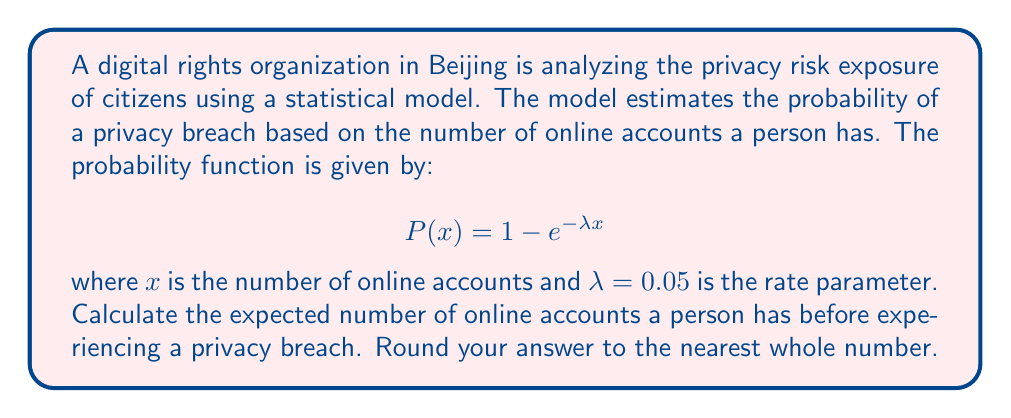Can you solve this math problem? To solve this problem, we need to understand that the given probability function follows an exponential distribution. The expected value (mean) of an exponential distribution is the inverse of its rate parameter.

Step 1: Identify the rate parameter
The rate parameter $\lambda$ is given as 0.05.

Step 2: Calculate the expected value
For an exponential distribution, the expected value E[X] is:

$$E[X] = \frac{1}{\lambda}$$

Substituting the value of $\lambda$:

$$E[X] = \frac{1}{0.05}$$

Step 3: Compute the result
$$E[X] = 20$$

Step 4: Round to the nearest whole number
Since we're asked to round to the nearest whole number, the final answer remains 20.

This result means that, on average, a person is expected to have 20 online accounts before experiencing a privacy breach, according to this statistical model.
Answer: 20 